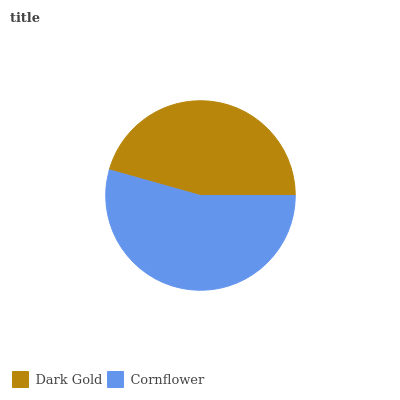Is Dark Gold the minimum?
Answer yes or no. Yes. Is Cornflower the maximum?
Answer yes or no. Yes. Is Cornflower the minimum?
Answer yes or no. No. Is Cornflower greater than Dark Gold?
Answer yes or no. Yes. Is Dark Gold less than Cornflower?
Answer yes or no. Yes. Is Dark Gold greater than Cornflower?
Answer yes or no. No. Is Cornflower less than Dark Gold?
Answer yes or no. No. Is Cornflower the high median?
Answer yes or no. Yes. Is Dark Gold the low median?
Answer yes or no. Yes. Is Dark Gold the high median?
Answer yes or no. No. Is Cornflower the low median?
Answer yes or no. No. 